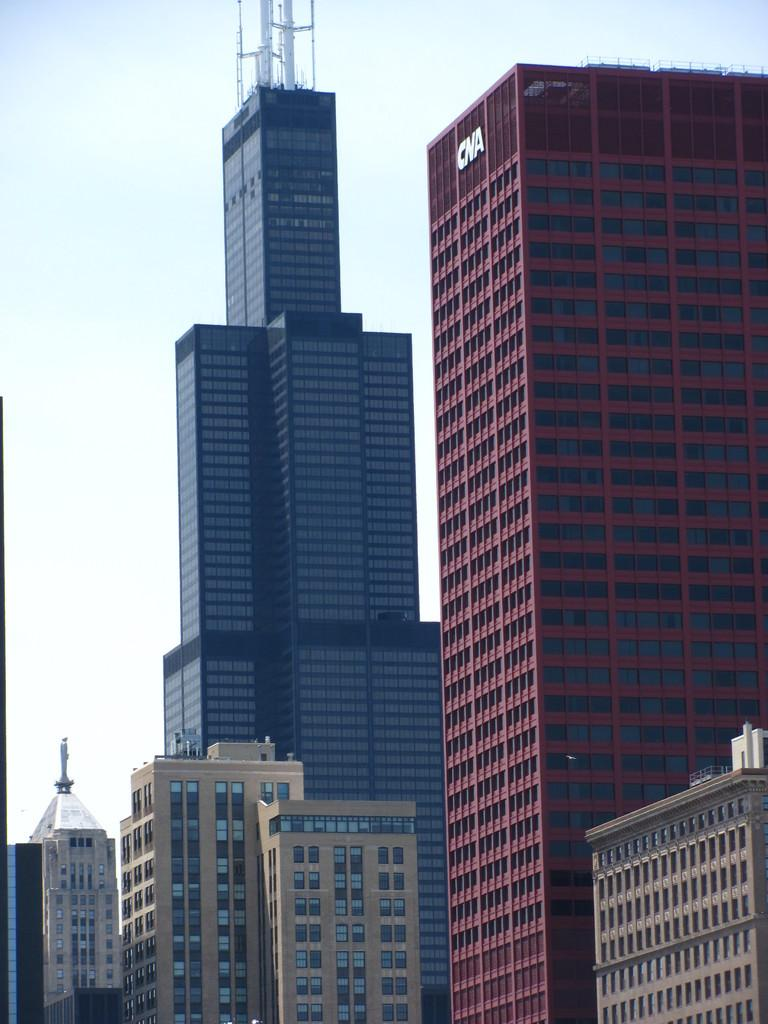What type of structures are present in the image? There are big buildings in the image. What part of the natural environment can be seen in the image? The sky is visible at the top of the image. What word is written on the mailbox in the image? There is no mailbox present in the image, so it is not possible to determine what word might be written on it. 